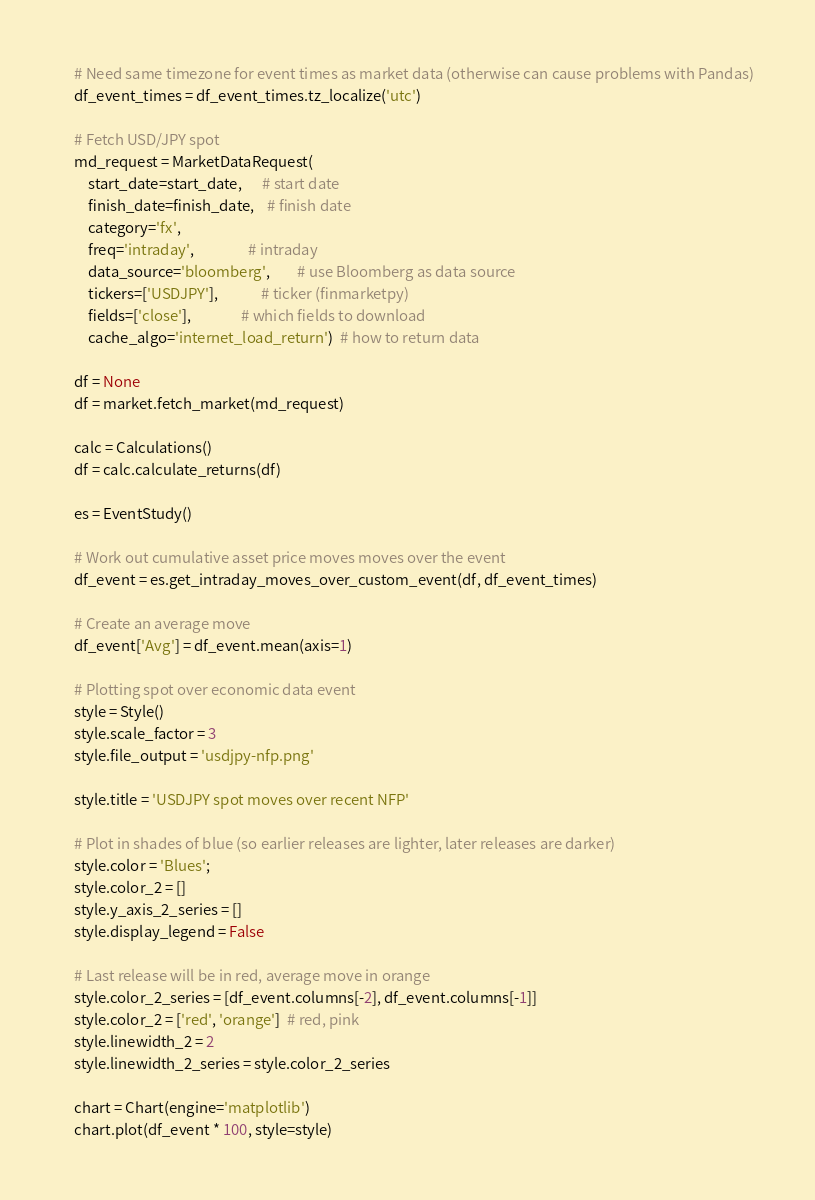Convert code to text. <code><loc_0><loc_0><loc_500><loc_500><_Python_>    # Need same timezone for event times as market data (otherwise can cause problems with Pandas)
    df_event_times = df_event_times.tz_localize('utc')

    # Fetch USD/JPY spot
    md_request = MarketDataRequest(
        start_date=start_date,      # start date
        finish_date=finish_date,    # finish date
        category='fx',
        freq='intraday',                # intraday
        data_source='bloomberg',        # use Bloomberg as data source
        tickers=['USDJPY'],             # ticker (finmarketpy)
        fields=['close'],               # which fields to download
        cache_algo='internet_load_return')  # how to return data

    df = None
    df = market.fetch_market(md_request)

    calc = Calculations()
    df = calc.calculate_returns(df)

    es = EventStudy()

    # Work out cumulative asset price moves moves over the event
    df_event = es.get_intraday_moves_over_custom_event(df, df_event_times)

    # Create an average move
    df_event['Avg'] = df_event.mean(axis=1)

    # Plotting spot over economic data event
    style = Style()
    style.scale_factor = 3
    style.file_output = 'usdjpy-nfp.png'

    style.title = 'USDJPY spot moves over recent NFP'

    # Plot in shades of blue (so earlier releases are lighter, later releases are darker)
    style.color = 'Blues';
    style.color_2 = []
    style.y_axis_2_series = []
    style.display_legend = False

    # Last release will be in red, average move in orange
    style.color_2_series = [df_event.columns[-2], df_event.columns[-1]]
    style.color_2 = ['red', 'orange']  # red, pink
    style.linewidth_2 = 2
    style.linewidth_2_series = style.color_2_series

    chart = Chart(engine='matplotlib')
    chart.plot(df_event * 100, style=style)
</code> 